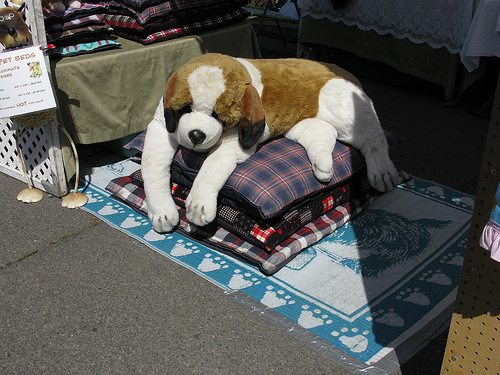<image>
Can you confirm if the pillow is next to the dog? No. The pillow is not positioned next to the dog. They are located in different areas of the scene. Is the pillow under the toy? Yes. The pillow is positioned underneath the toy, with the toy above it in the vertical space. Where is the puppy in relation to the sign? Is it on the sign? No. The puppy is not positioned on the sign. They may be near each other, but the puppy is not supported by or resting on top of the sign. 